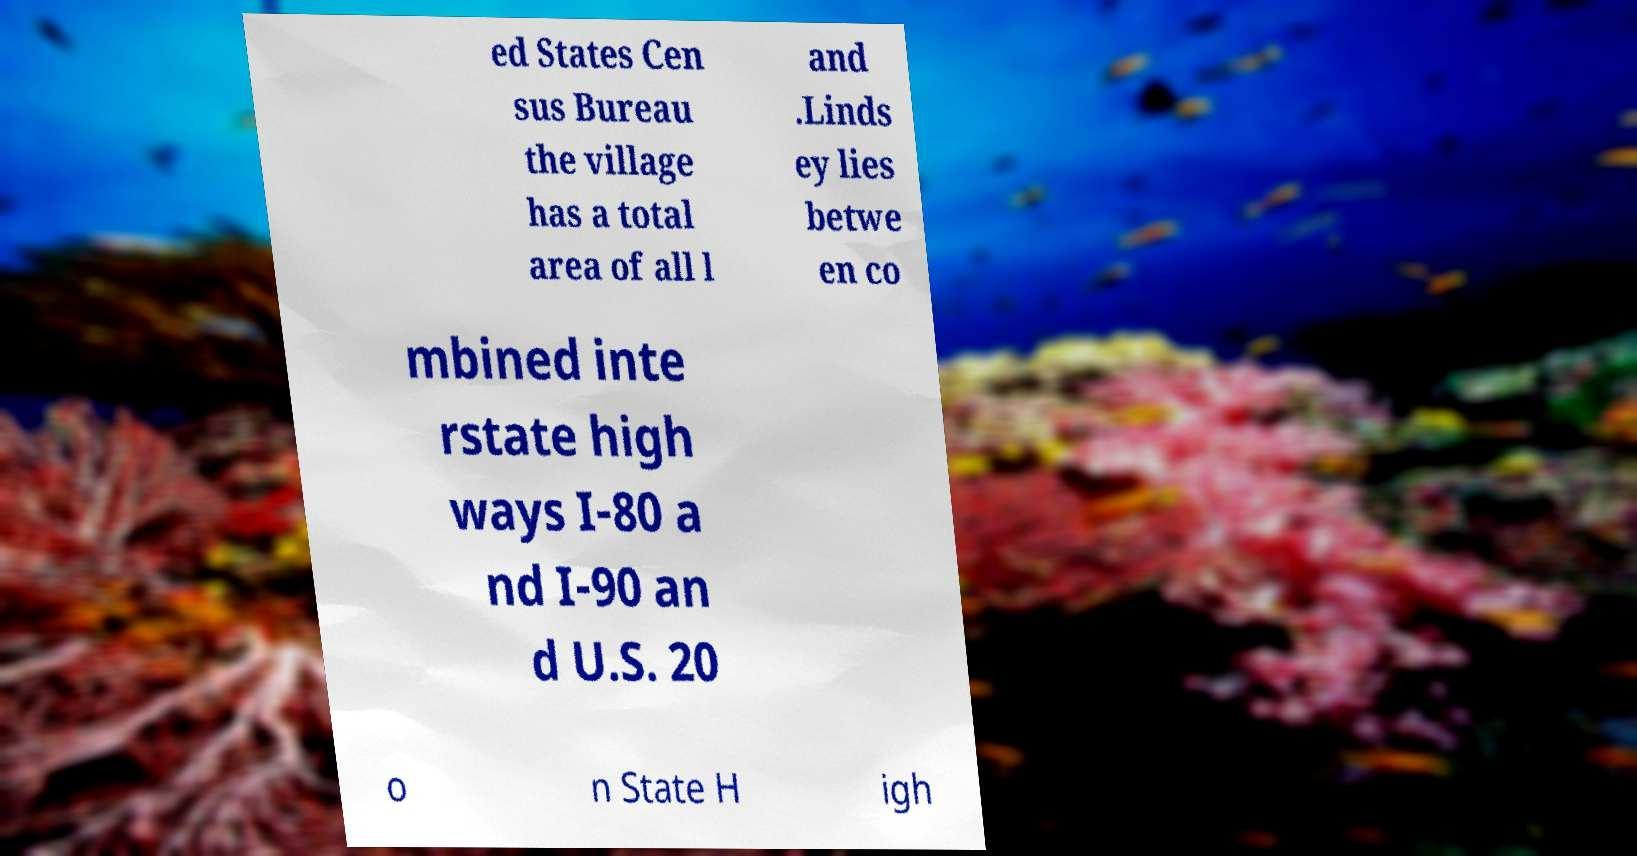Can you accurately transcribe the text from the provided image for me? ed States Cen sus Bureau the village has a total area of all l and .Linds ey lies betwe en co mbined inte rstate high ways I-80 a nd I-90 an d U.S. 20 o n State H igh 